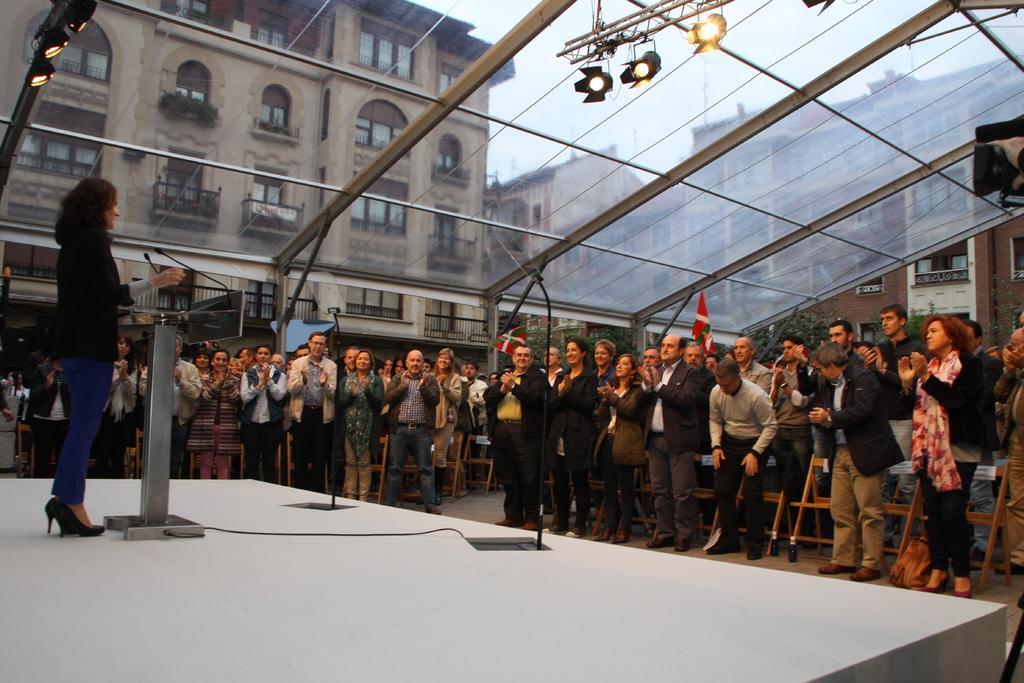Please provide a concise description of this image. In this image I can group of people are standing. Here I can see a woman is standing on the stage. The woman is standing in front of a podium. On the podium I can see microphones. In the background I can see buildings, stage lights, framed glass wall and the sky. 